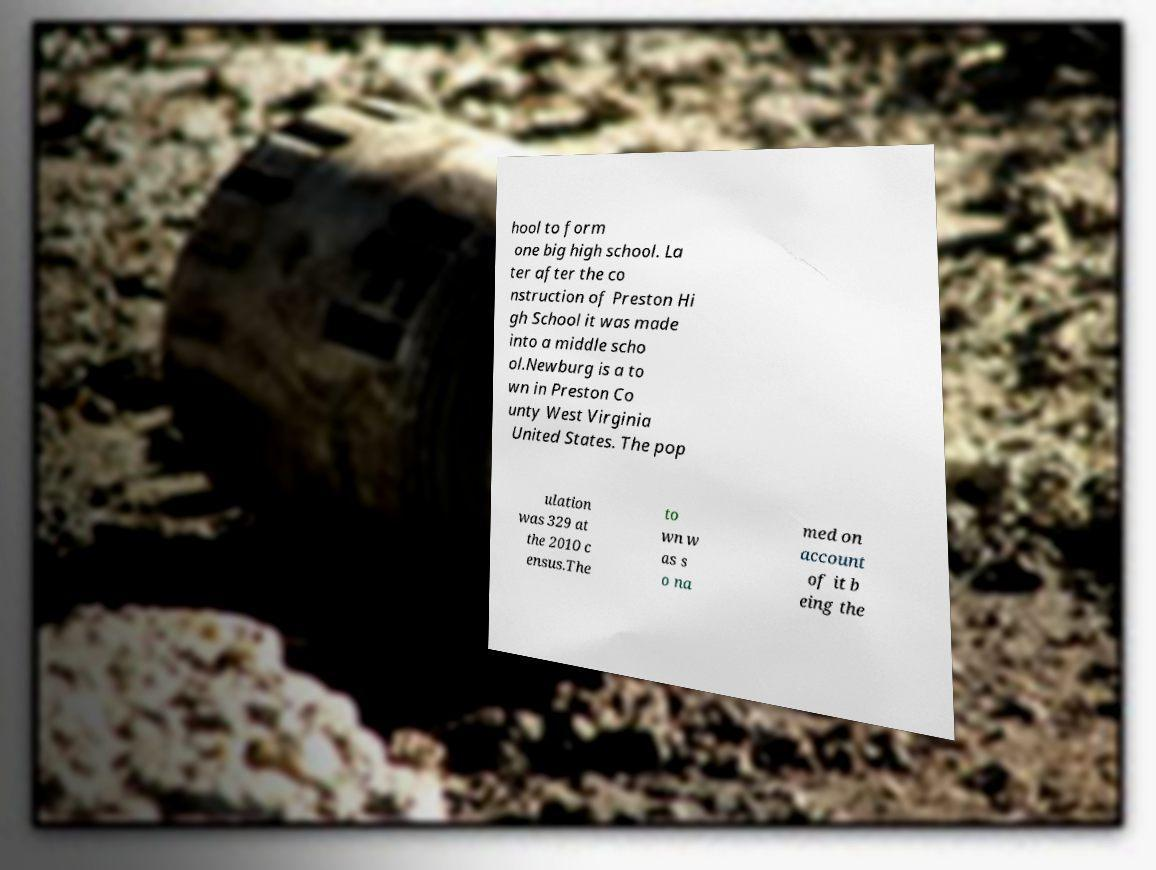There's text embedded in this image that I need extracted. Can you transcribe it verbatim? hool to form one big high school. La ter after the co nstruction of Preston Hi gh School it was made into a middle scho ol.Newburg is a to wn in Preston Co unty West Virginia United States. The pop ulation was 329 at the 2010 c ensus.The to wn w as s o na med on account of it b eing the 